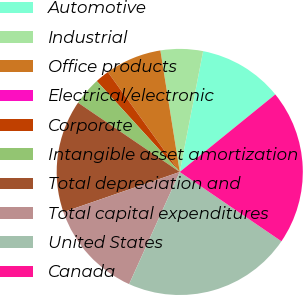Convert chart to OTSL. <chart><loc_0><loc_0><loc_500><loc_500><pie_chart><fcel>Automotive<fcel>Industrial<fcel>Office products<fcel>Electrical/electronic<fcel>Corporate<fcel>Intangible asset amortization<fcel>Total depreciation and<fcel>Total capital expenditures<fcel>United States<fcel>Canada<nl><fcel>11.11%<fcel>5.56%<fcel>7.41%<fcel>0.0%<fcel>1.85%<fcel>3.71%<fcel>14.81%<fcel>12.96%<fcel>22.22%<fcel>20.37%<nl></chart> 